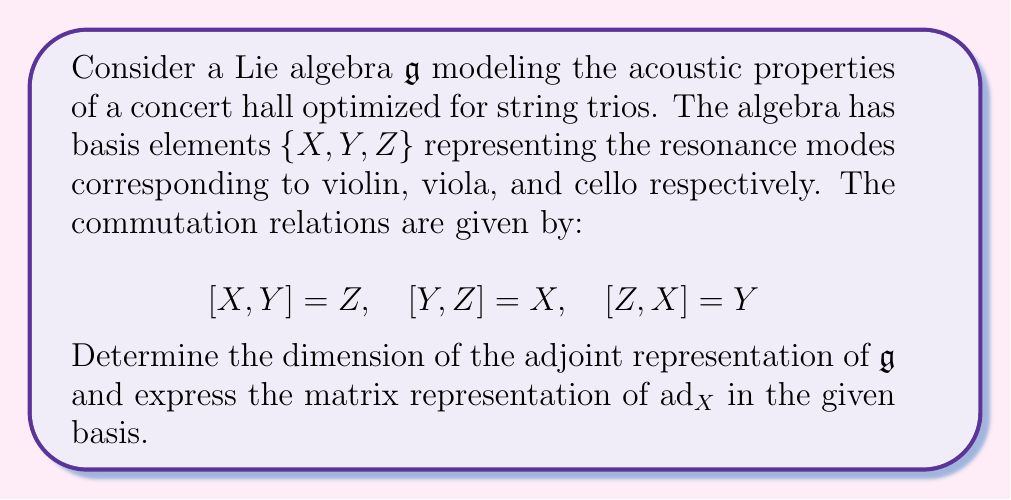Can you answer this question? To solve this problem, we'll follow these steps:

1) First, recall that the dimension of the adjoint representation of a Lie algebra is equal to the dimension of the algebra itself. In this case, we have three basis elements, so:

   $\dim(\text{ad}_\mathfrak{g}) = \dim(\mathfrak{g}) = 3$

2) To find the matrix representation of $\text{ad}_X$, we need to calculate how $X$ acts on each basis element under the adjoint action. The adjoint action is defined by the Lie bracket:

   $\text{ad}_X(Y) = [X,Y]$

3) Let's calculate each column of the matrix:

   For $X$: $\text{ad}_X(X) = [X,X] = 0$
   For $Y$: $\text{ad}_X(Y) = [X,Y] = Z$
   For $Z$: $\text{ad}_X(Z) = [X,Z] = -Y$ (using the antisymmetry of the Lie bracket)

4) Now we can express these results as column vectors in the given basis $\{X,Y,Z\}$:

   $\text{ad}_X(X) = \begin{pmatrix} 0 \\ 0 \\ 0 \end{pmatrix}$

   $\text{ad}_X(Y) = \begin{pmatrix} 0 \\ 0 \\ 1 \end{pmatrix}$

   $\text{ad}_X(Z) = \begin{pmatrix} 0 \\ -1 \\ 0 \end{pmatrix}$

5) Combining these columns gives us the matrix representation of $\text{ad}_X$:

   $\text{ad}_X = \begin{pmatrix} 
   0 & 0 & 0 \\
   0 & 0 & -1 \\
   0 & 1 & 0
   \end{pmatrix}$

This matrix representation perfectly captures how the resonance mode of the violin (represented by $X$) interacts with the other modes in our optimized concert hall for string trios.
Answer: The dimension of the adjoint representation is 3, and the matrix representation of $\text{ad}_X$ is:

$$\text{ad}_X = \begin{pmatrix} 
0 & 0 & 0 \\
0 & 0 & -1 \\
0 & 1 & 0
\end{pmatrix}$$ 